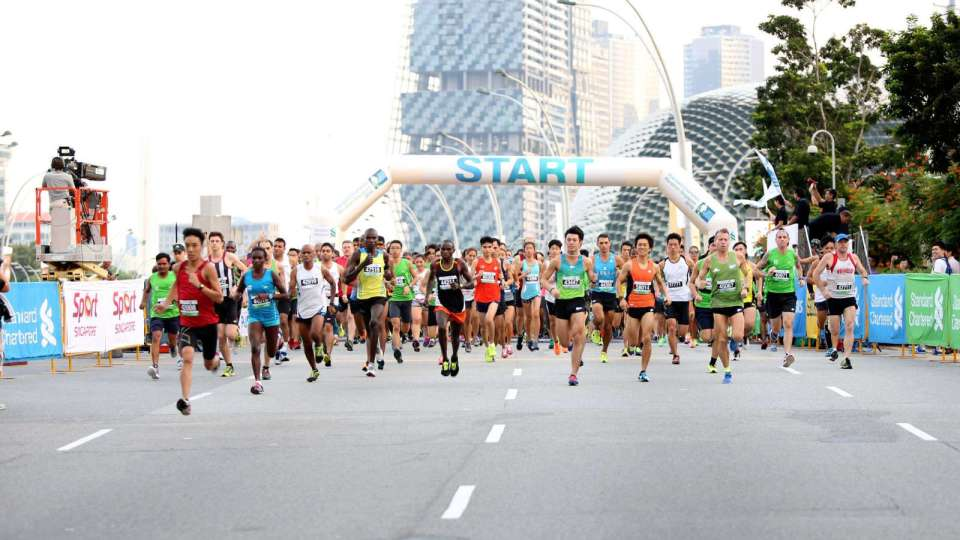Imagine you are one of the runners in this image. Describe your thoughts and feelings just as the race starts. As a runner poised at the start line, my heart races with anticipation and adrenaline. The buzz of the crowd and the rhythmic footsteps of my fellow participants create an electrifying atmosphere. I'm determined to pace myself wisely, harnessing this surge of excitement to push through the race. Suppose the race track passes through iconic landmarks. What might be some features or experiences a runner would witness during the race? During the run, participants might traverse through key locations showcasing stunning architecture and cultural landmarks, possibly enjoying diverse cityscapes—from bustling urban settings to serene parks. Runners often experience a mixture of scenic beauty, supportive spectators, and strategically placed refreshment stations, all adding to the unique charm and challenge of the race. 